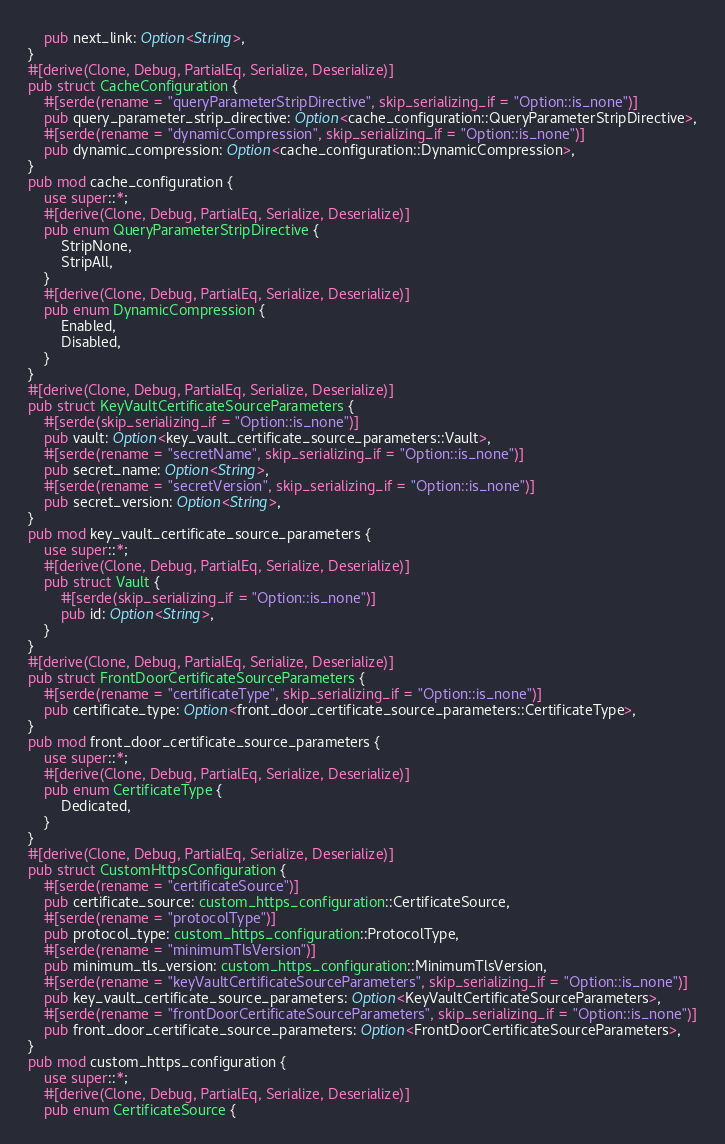<code> <loc_0><loc_0><loc_500><loc_500><_Rust_>    pub next_link: Option<String>,
}
#[derive(Clone, Debug, PartialEq, Serialize, Deserialize)]
pub struct CacheConfiguration {
    #[serde(rename = "queryParameterStripDirective", skip_serializing_if = "Option::is_none")]
    pub query_parameter_strip_directive: Option<cache_configuration::QueryParameterStripDirective>,
    #[serde(rename = "dynamicCompression", skip_serializing_if = "Option::is_none")]
    pub dynamic_compression: Option<cache_configuration::DynamicCompression>,
}
pub mod cache_configuration {
    use super::*;
    #[derive(Clone, Debug, PartialEq, Serialize, Deserialize)]
    pub enum QueryParameterStripDirective {
        StripNone,
        StripAll,
    }
    #[derive(Clone, Debug, PartialEq, Serialize, Deserialize)]
    pub enum DynamicCompression {
        Enabled,
        Disabled,
    }
}
#[derive(Clone, Debug, PartialEq, Serialize, Deserialize)]
pub struct KeyVaultCertificateSourceParameters {
    #[serde(skip_serializing_if = "Option::is_none")]
    pub vault: Option<key_vault_certificate_source_parameters::Vault>,
    #[serde(rename = "secretName", skip_serializing_if = "Option::is_none")]
    pub secret_name: Option<String>,
    #[serde(rename = "secretVersion", skip_serializing_if = "Option::is_none")]
    pub secret_version: Option<String>,
}
pub mod key_vault_certificate_source_parameters {
    use super::*;
    #[derive(Clone, Debug, PartialEq, Serialize, Deserialize)]
    pub struct Vault {
        #[serde(skip_serializing_if = "Option::is_none")]
        pub id: Option<String>,
    }
}
#[derive(Clone, Debug, PartialEq, Serialize, Deserialize)]
pub struct FrontDoorCertificateSourceParameters {
    #[serde(rename = "certificateType", skip_serializing_if = "Option::is_none")]
    pub certificate_type: Option<front_door_certificate_source_parameters::CertificateType>,
}
pub mod front_door_certificate_source_parameters {
    use super::*;
    #[derive(Clone, Debug, PartialEq, Serialize, Deserialize)]
    pub enum CertificateType {
        Dedicated,
    }
}
#[derive(Clone, Debug, PartialEq, Serialize, Deserialize)]
pub struct CustomHttpsConfiguration {
    #[serde(rename = "certificateSource")]
    pub certificate_source: custom_https_configuration::CertificateSource,
    #[serde(rename = "protocolType")]
    pub protocol_type: custom_https_configuration::ProtocolType,
    #[serde(rename = "minimumTlsVersion")]
    pub minimum_tls_version: custom_https_configuration::MinimumTlsVersion,
    #[serde(rename = "keyVaultCertificateSourceParameters", skip_serializing_if = "Option::is_none")]
    pub key_vault_certificate_source_parameters: Option<KeyVaultCertificateSourceParameters>,
    #[serde(rename = "frontDoorCertificateSourceParameters", skip_serializing_if = "Option::is_none")]
    pub front_door_certificate_source_parameters: Option<FrontDoorCertificateSourceParameters>,
}
pub mod custom_https_configuration {
    use super::*;
    #[derive(Clone, Debug, PartialEq, Serialize, Deserialize)]
    pub enum CertificateSource {</code> 